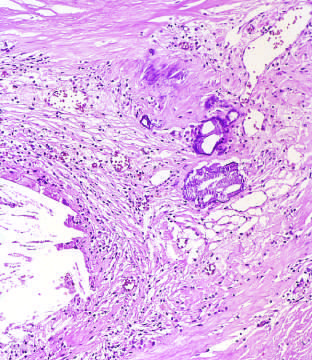what shows scattered inflammatory cells, calcification arrowheads, and neovascularization?
Answer the question using a single word or phrase. High-power view of the junction of the fibrous cap and core 